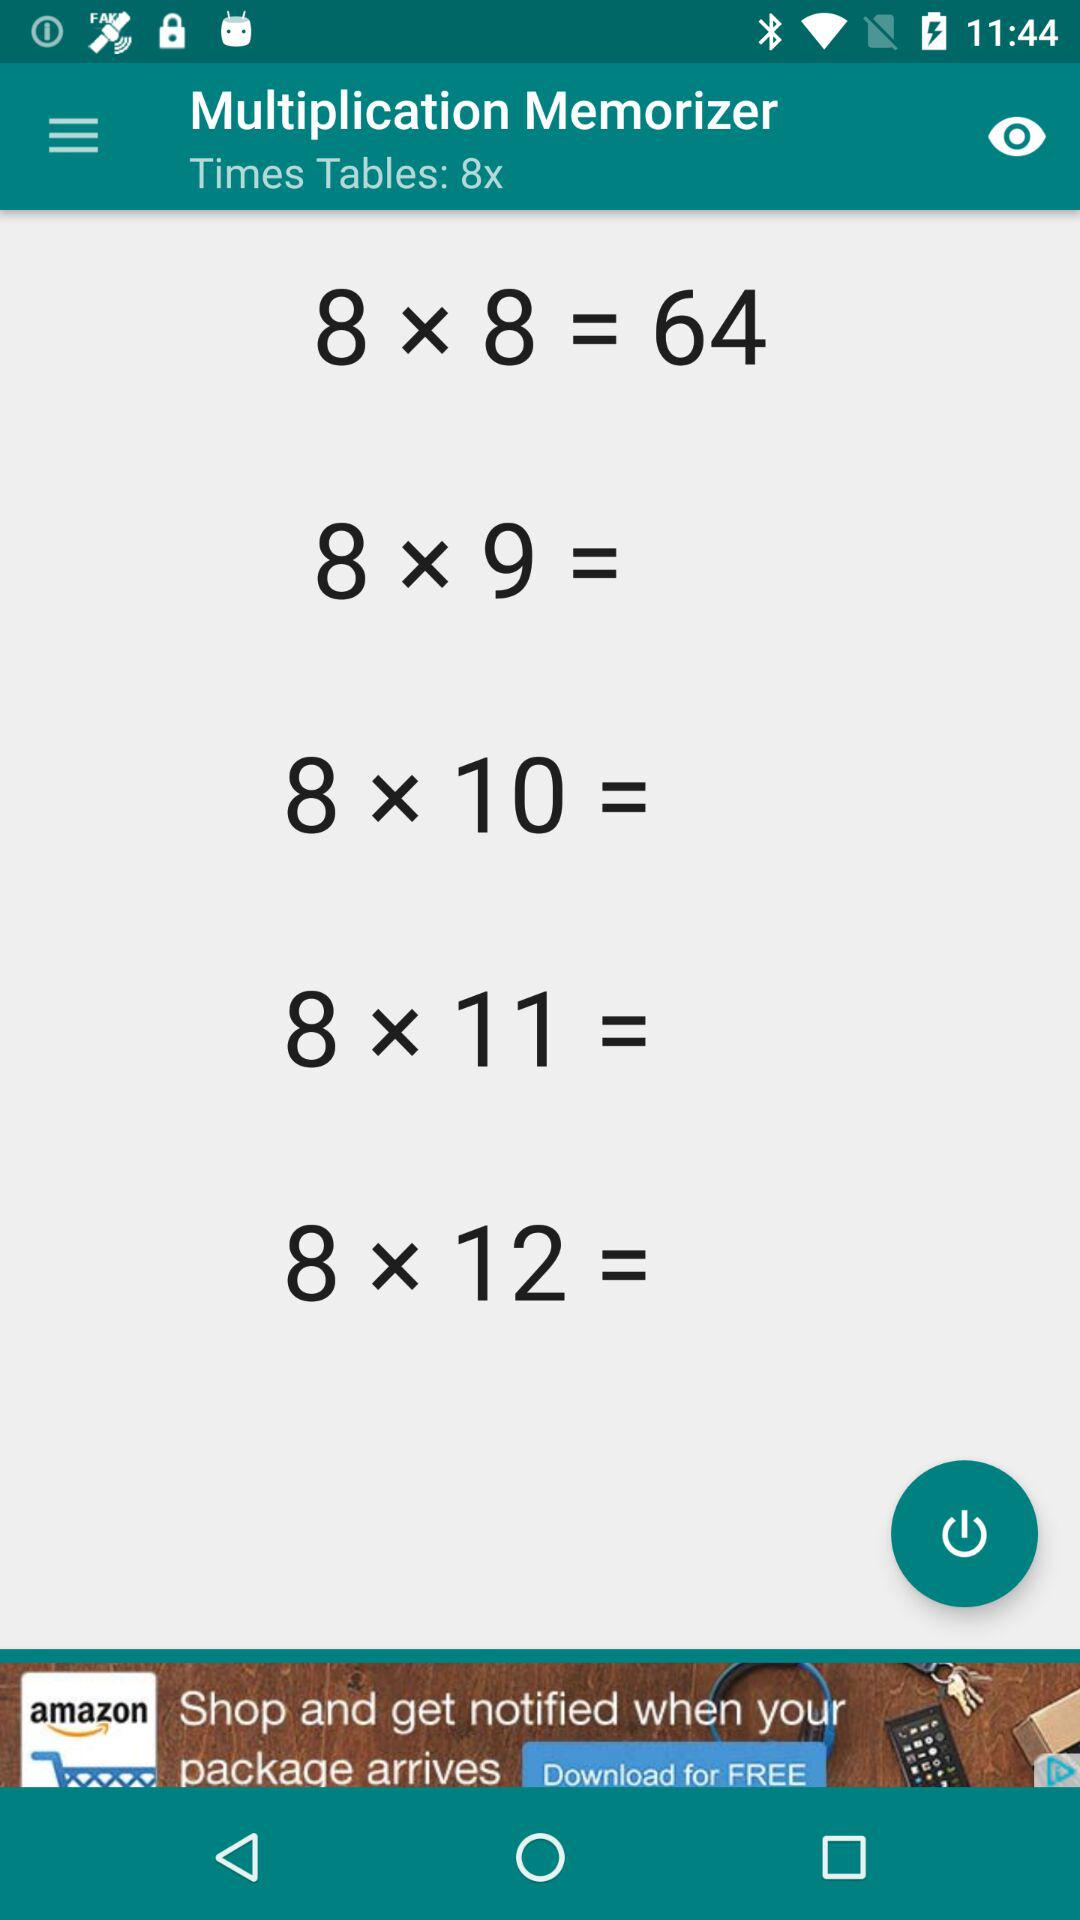What is the name of the application? The name of the application is "Multiplication Memorizer". 